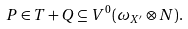<formula> <loc_0><loc_0><loc_500><loc_500>P \in T + Q \subseteq V ^ { 0 } ( \omega _ { X ^ { \prime } } \otimes N ) .</formula> 